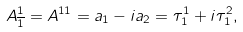<formula> <loc_0><loc_0><loc_500><loc_500>A _ { \overline { 1 } } ^ { 1 } = A ^ { 1 1 } = a _ { 1 } - i a _ { 2 } = \tau _ { 1 } ^ { 1 } + i \tau _ { 1 } ^ { 2 } ,</formula> 